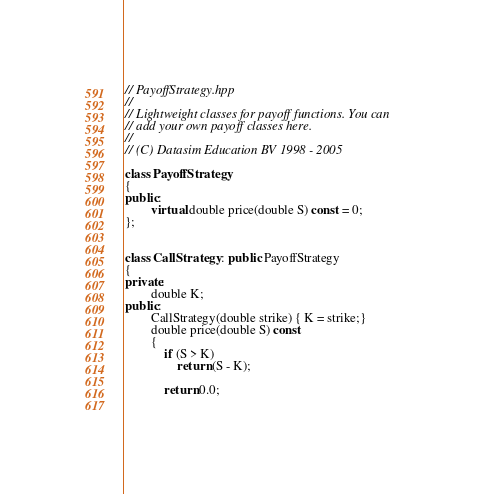<code> <loc_0><loc_0><loc_500><loc_500><_C++_>// PayoffStrategy.hpp
//
// Lightweight classes for payoff functions. You can 
// add your own payoff classes here.
//
// (C) Datasim Education BV 1998 - 2005

class PayoffStrategy
{
public:
		virtual double price(double S) const = 0;
};


class CallStrategy : public PayoffStrategy
{
private:
		double K;
public:
		CallStrategy(double strike) { K = strike;}
		double price(double S) const
		{
			if (S > K)
				return (S - K);
		
			return 0.0;
	</code> 